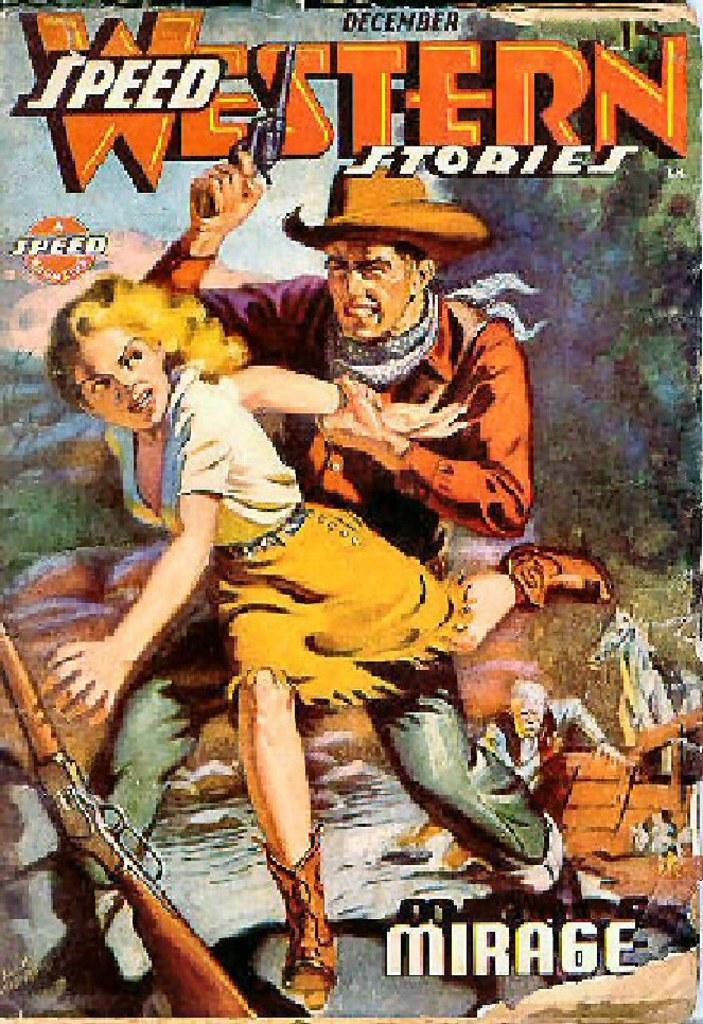Provide a one-sentence caption for the provided image. An old magazine called Speed Western Stories, Mirage. 